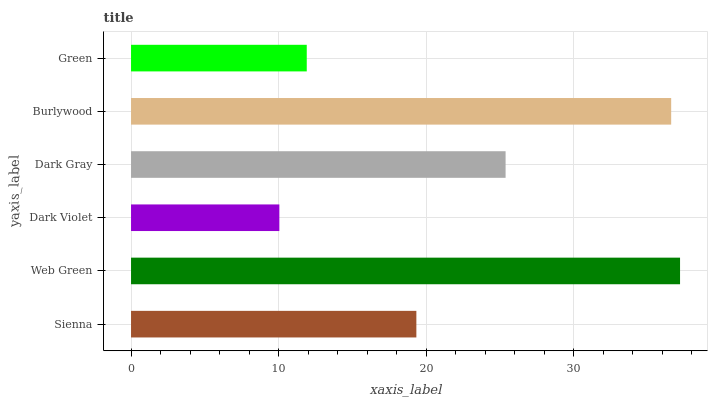Is Dark Violet the minimum?
Answer yes or no. Yes. Is Web Green the maximum?
Answer yes or no. Yes. Is Web Green the minimum?
Answer yes or no. No. Is Dark Violet the maximum?
Answer yes or no. No. Is Web Green greater than Dark Violet?
Answer yes or no. Yes. Is Dark Violet less than Web Green?
Answer yes or no. Yes. Is Dark Violet greater than Web Green?
Answer yes or no. No. Is Web Green less than Dark Violet?
Answer yes or no. No. Is Dark Gray the high median?
Answer yes or no. Yes. Is Sienna the low median?
Answer yes or no. Yes. Is Web Green the high median?
Answer yes or no. No. Is Dark Violet the low median?
Answer yes or no. No. 